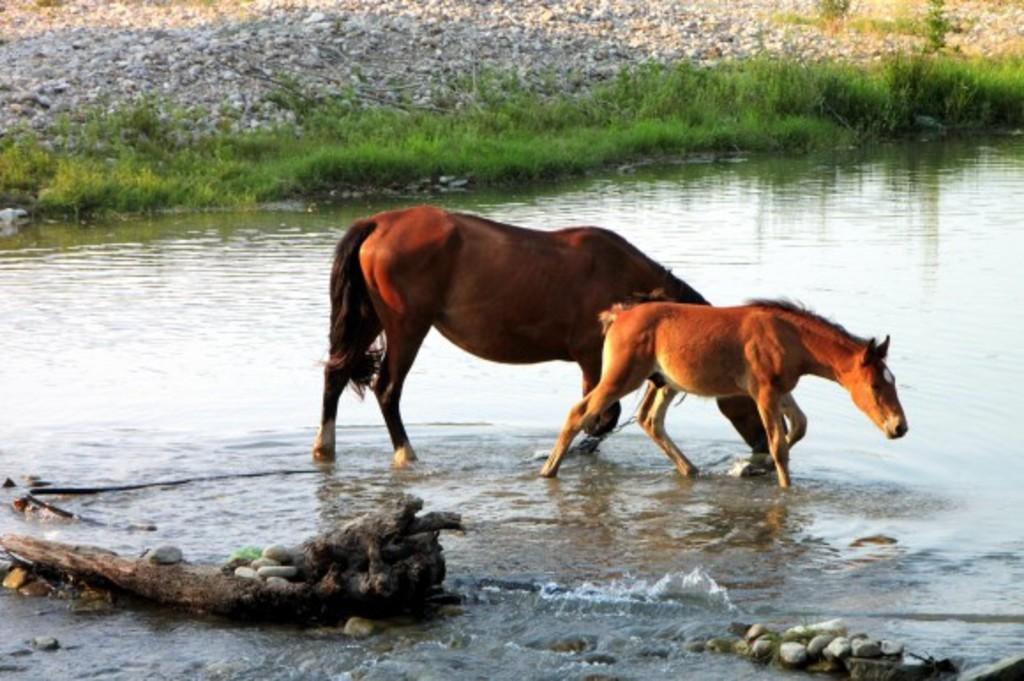How many horses are in the image? There are two horses in the image. What are the horses doing in the image? The horses are standing in the water. What can be seen in the background of the image? There are rocks and grass visible in the background of the image. What type of wrench is being used by the creature in the image? There is no creature or wrench present in the image; it features two horses standing in the water. 